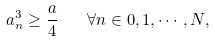Convert formula to latex. <formula><loc_0><loc_0><loc_500><loc_500>a _ { n } ^ { 3 } \geq \frac { a } { 4 } \quad \forall n \in 0 , 1 , \cdots , N ,</formula> 